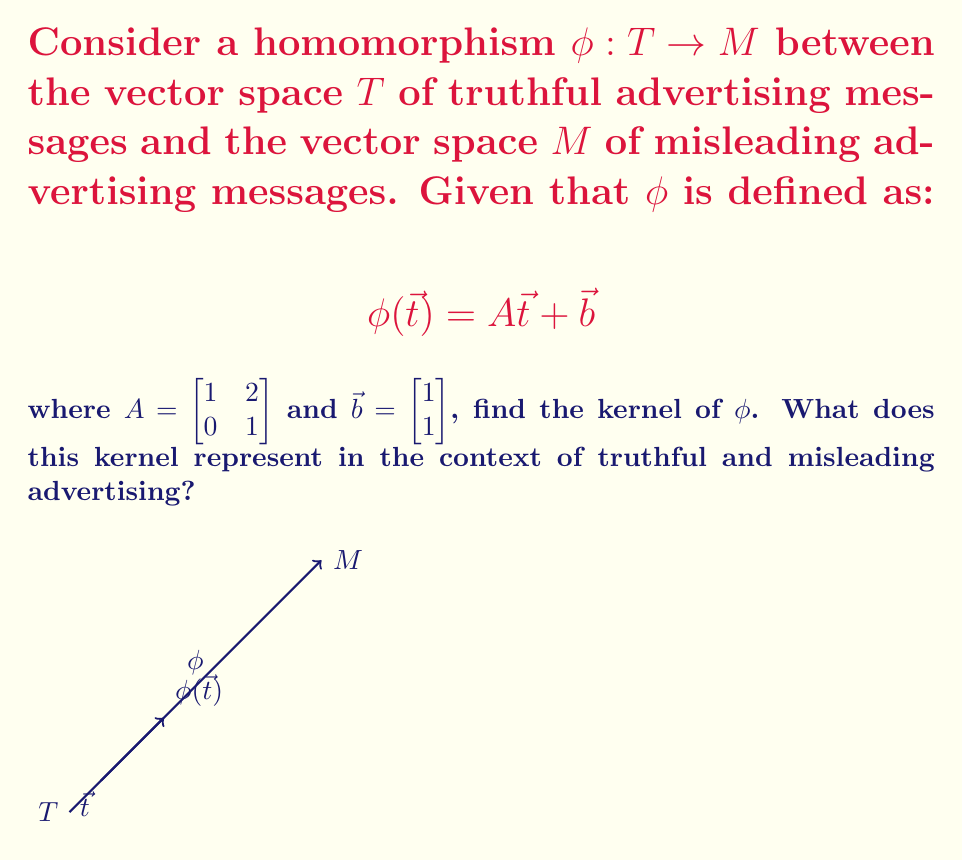Give your solution to this math problem. To find the kernel of $\phi$, we need to solve the equation $\phi(\vec{t}) = \vec{0}$:

1) Set up the equation:
   $$A\vec{t} + \vec{b} = \vec{0}$$

2) Substitute the given values:
   $$\begin{bmatrix} 1 & 2 \\ 0 & 1 \end{bmatrix}\begin{bmatrix} t_1 \\ t_2 \end{bmatrix} + \begin{bmatrix} 1 \\ 1 \end{bmatrix} = \begin{bmatrix} 0 \\ 0 \end{bmatrix}$$

3) Expand the matrix multiplication:
   $$\begin{bmatrix} t_1 + 2t_2 + 1 \\ t_2 + 1 \end{bmatrix} = \begin{bmatrix} 0 \\ 0 \end{bmatrix}$$

4) Set up a system of equations:
   $$t_1 + 2t_2 + 1 = 0$$
   $$t_2 + 1 = 0$$

5) Solve the system:
   From the second equation: $t_2 = -1$
   Substitute into the first equation:
   $t_1 + 2(-1) + 1 = 0$
   $t_1 - 1 = 0$
   $t_1 = 1$

6) Therefore, the kernel is:
   $$\text{ker}(\phi) = \{\vec{t} \in T \mid \vec{t} = \begin{bmatrix} 1 \\ -1 \end{bmatrix}\}$$

In the context of truthful and misleading advertising, the kernel represents the set of truthful messages that, when transformed by $\phi$, result in no misleading content. In other words, these are the truthful messages that remain unchanged in their truthfulness even after being subjected to potentially deceptive practices.
Answer: $\text{ker}(\phi) = \{\begin{bmatrix} 1 \\ -1 \end{bmatrix}\}$ 